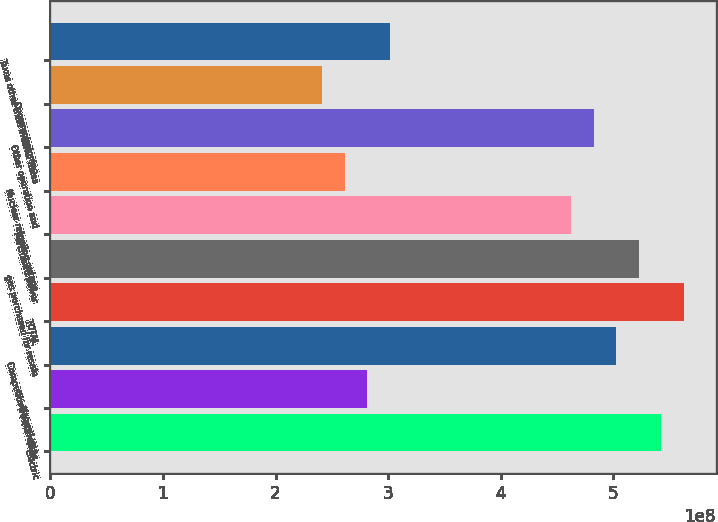Convert chart to OTSL. <chart><loc_0><loc_0><loc_500><loc_500><bar_chart><fcel>Electric<fcel>Natural gas<fcel>Competitive businesses<fcel>TOTAL<fcel>gas purchased for resale<fcel>Purchased power<fcel>Nuclear refueling outage<fcel>Other operation and<fcel>Decommissioning<fcel>Taxes other than income taxes<nl><fcel>5.42731e+08<fcel>2.81416e+08<fcel>5.02529e+08<fcel>5.62832e+08<fcel>5.2263e+08<fcel>4.62327e+08<fcel>2.61315e+08<fcel>4.82428e+08<fcel>2.41214e+08<fcel>3.01517e+08<nl></chart> 